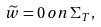Convert formula to latex. <formula><loc_0><loc_0><loc_500><loc_500>\widetilde { w } = 0 \, o n \, \Sigma _ { T } ,</formula> 